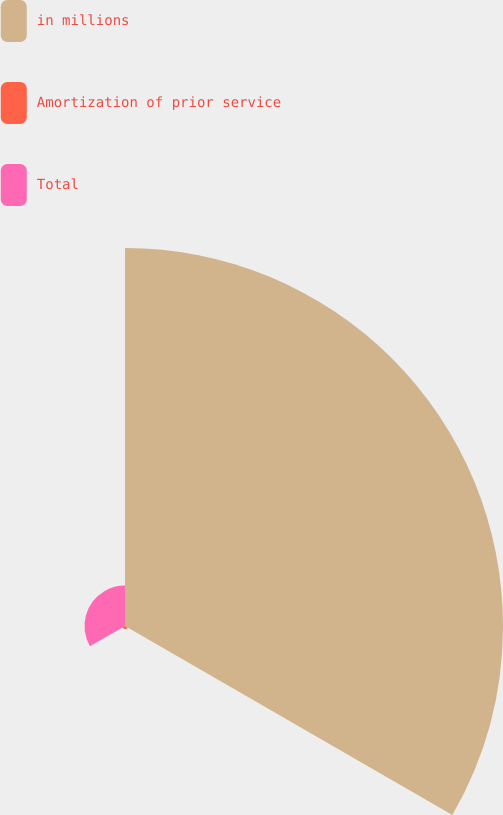<chart> <loc_0><loc_0><loc_500><loc_500><pie_chart><fcel>in millions<fcel>Amortization of prior service<fcel>Total<nl><fcel>89.68%<fcel>0.71%<fcel>9.61%<nl></chart> 